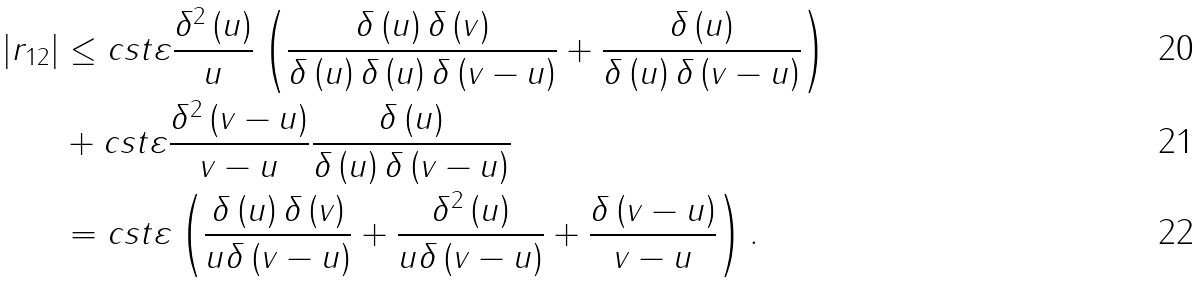Convert formula to latex. <formula><loc_0><loc_0><loc_500><loc_500>\left | r _ { 1 2 } \right | & \leq c s t \varepsilon \frac { \delta ^ { 2 } \left ( u \right ) } { u } \left ( \frac { \delta \left ( u \right ) \delta \left ( v \right ) } { \delta \left ( u \right ) \delta \left ( u \right ) \delta \left ( v - u \right ) } + \frac { \delta \left ( u \right ) } { \delta \left ( u \right ) \delta \left ( v - u \right ) } \right ) \\ & + c s t \varepsilon \frac { \delta ^ { 2 } \left ( v - u \right ) } { v - u } \frac { \delta \left ( u \right ) } { \delta \left ( u \right ) \delta \left ( v - u \right ) } \\ & = c s t \varepsilon \left ( \frac { \delta \left ( u \right ) \delta \left ( v \right ) } { u \delta \left ( v - u \right ) } + \frac { \delta ^ { 2 } \left ( u \right ) } { u \delta \left ( v - u \right ) } + \frac { \delta \left ( v - u \right ) } { v - u } \right ) .</formula> 